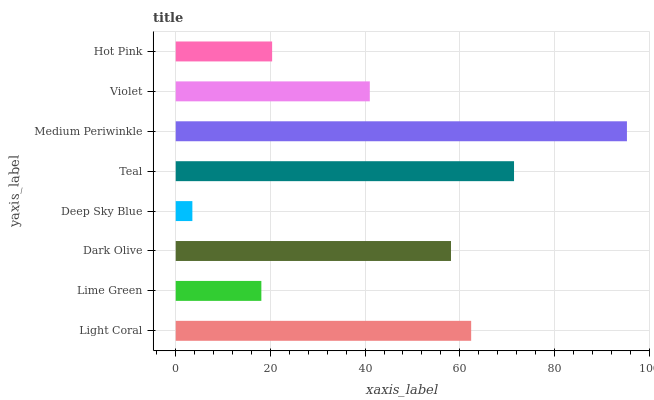Is Deep Sky Blue the minimum?
Answer yes or no. Yes. Is Medium Periwinkle the maximum?
Answer yes or no. Yes. Is Lime Green the minimum?
Answer yes or no. No. Is Lime Green the maximum?
Answer yes or no. No. Is Light Coral greater than Lime Green?
Answer yes or no. Yes. Is Lime Green less than Light Coral?
Answer yes or no. Yes. Is Lime Green greater than Light Coral?
Answer yes or no. No. Is Light Coral less than Lime Green?
Answer yes or no. No. Is Dark Olive the high median?
Answer yes or no. Yes. Is Violet the low median?
Answer yes or no. Yes. Is Violet the high median?
Answer yes or no. No. Is Deep Sky Blue the low median?
Answer yes or no. No. 